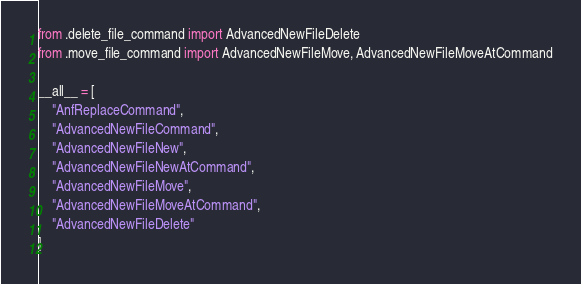<code> <loc_0><loc_0><loc_500><loc_500><_Python_>from .delete_file_command import AdvancedNewFileDelete
from .move_file_command import AdvancedNewFileMove, AdvancedNewFileMoveAtCommand

__all__ = [
    "AnfReplaceCommand",
    "AdvancedNewFileCommand",
    "AdvancedNewFileNew",
    "AdvancedNewFileNewAtCommand",
    "AdvancedNewFileMove",
    "AdvancedNewFileMoveAtCommand",
    "AdvancedNewFileDelete"
]
</code> 